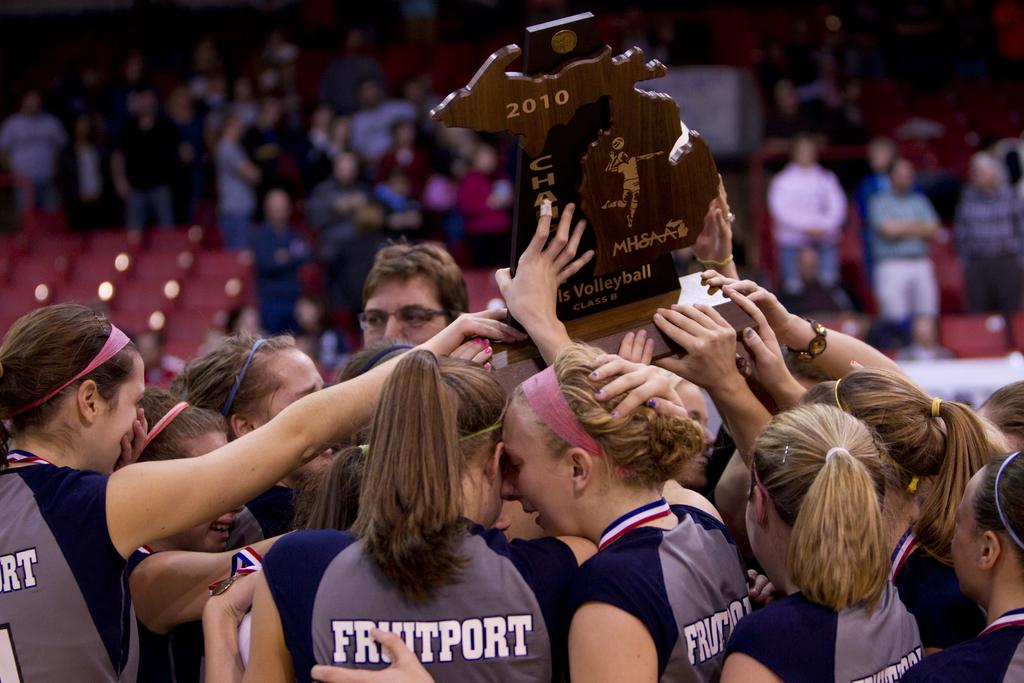<image>
Provide a brief description of the given image. Women from the Fruitport team hold up a trophy dated 2010. 